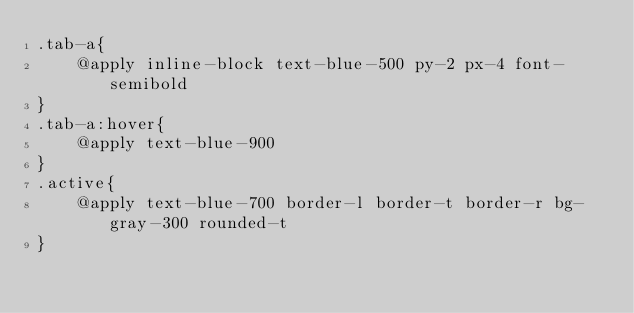Convert code to text. <code><loc_0><loc_0><loc_500><loc_500><_CSS_>.tab-a{
    @apply inline-block text-blue-500 py-2 px-4 font-semibold
}
.tab-a:hover{
    @apply text-blue-900
}
.active{
    @apply text-blue-700 border-l border-t border-r bg-gray-300 rounded-t
}</code> 